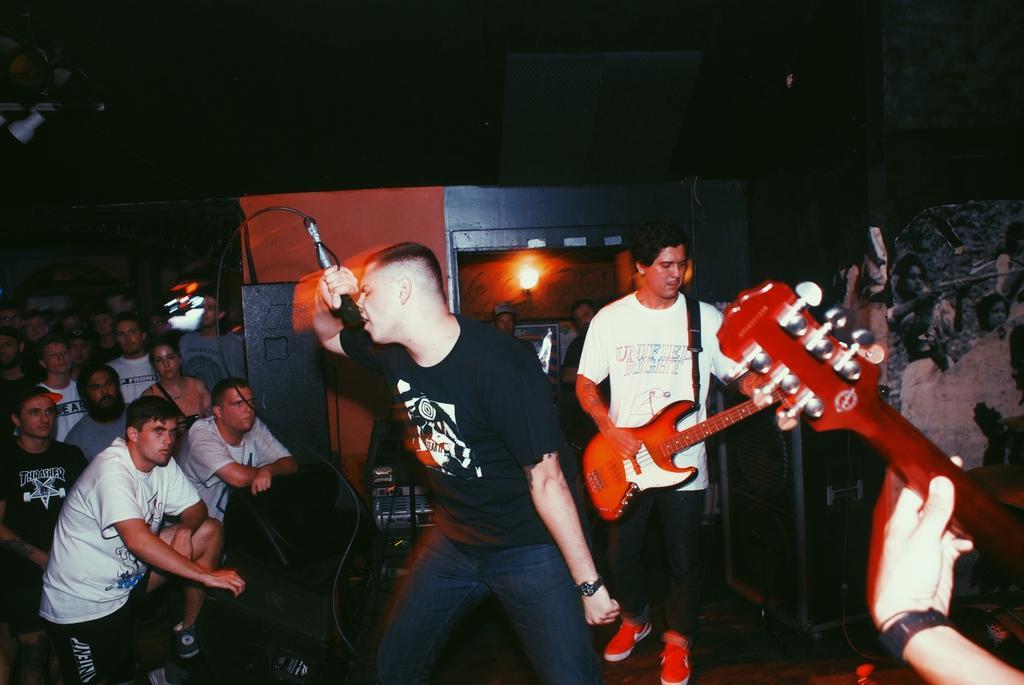Can you describe this image briefly? In the middle of the image I can see a man standing and singing a song. He's holding a mike in his right hand. At the back of this person there is another man standing and playing the guitar. In the background I can see few people are standing and looking at these persons. 